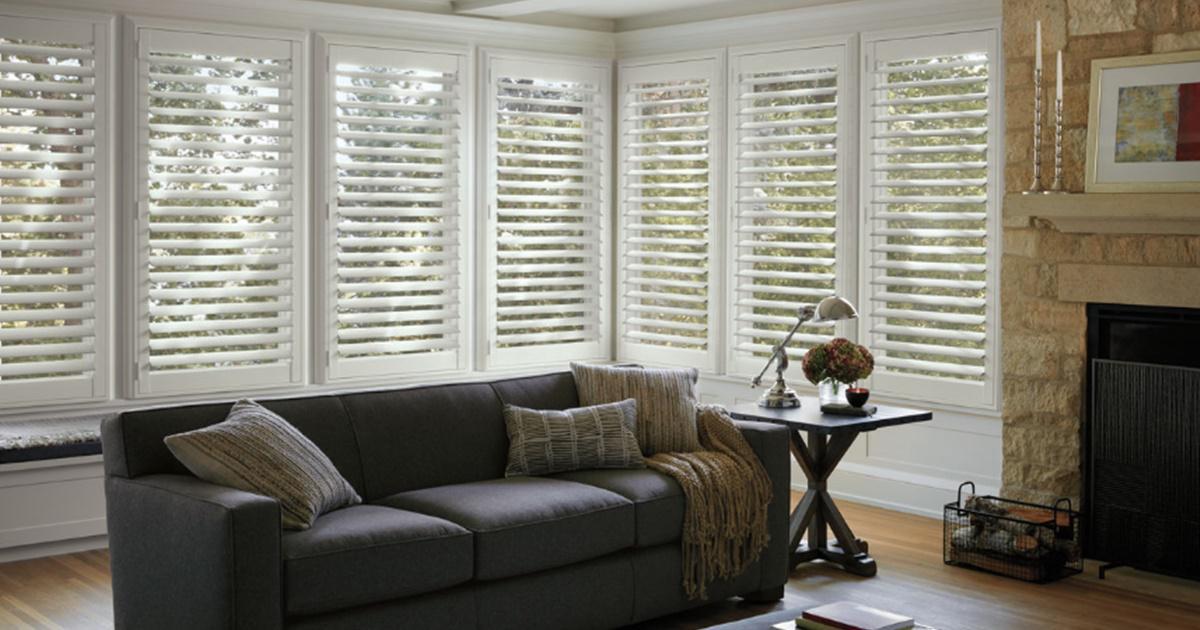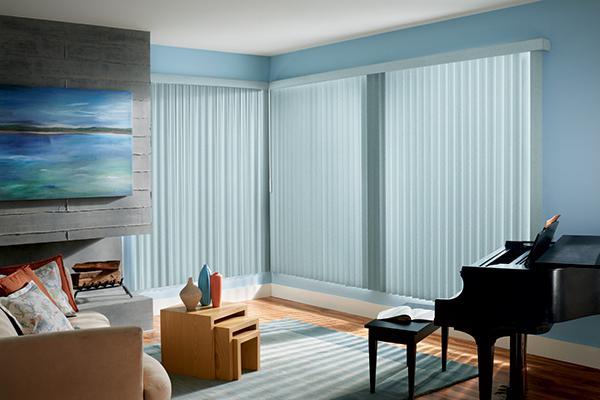The first image is the image on the left, the second image is the image on the right. Analyze the images presented: Is the assertion "In at least one image there is a grey four seat sofa in front of three white open blinds." valid? Answer yes or no. No. 